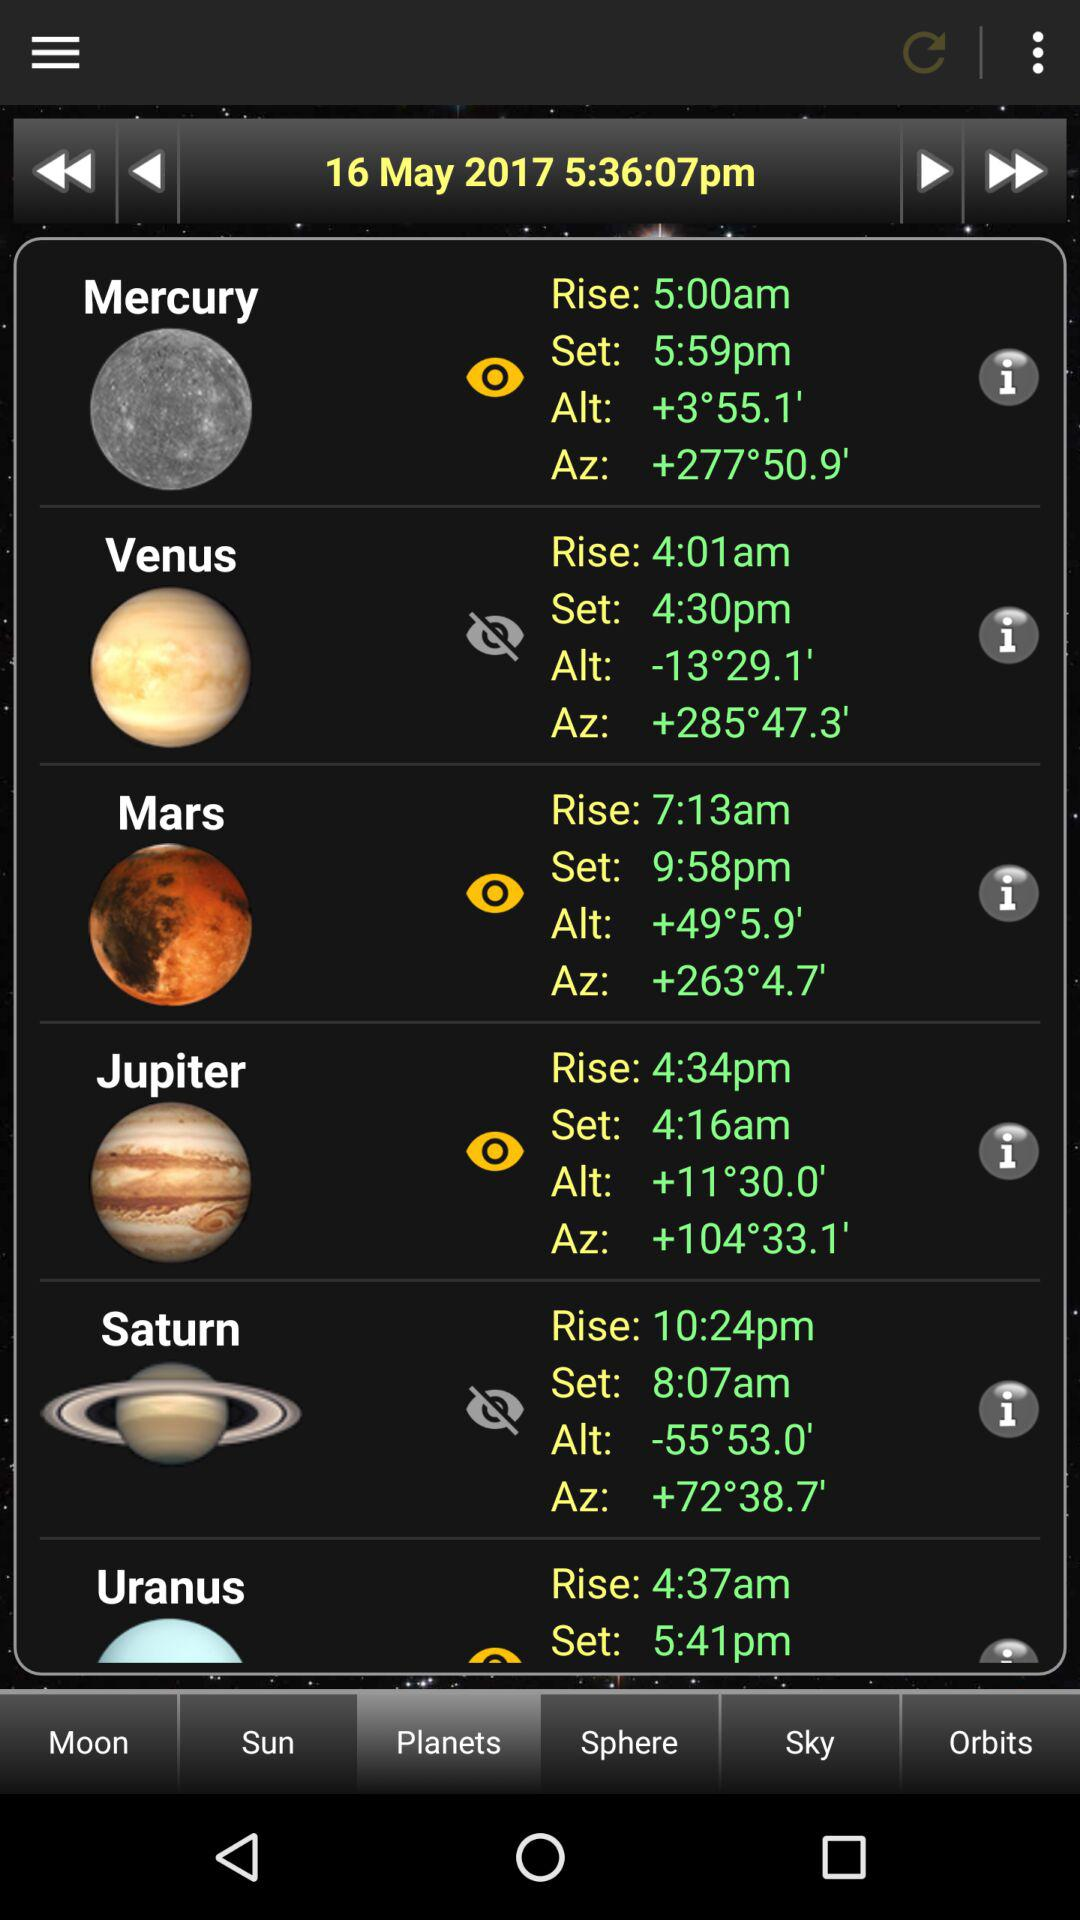Which tab is selected? The selected tab is "Planets". 